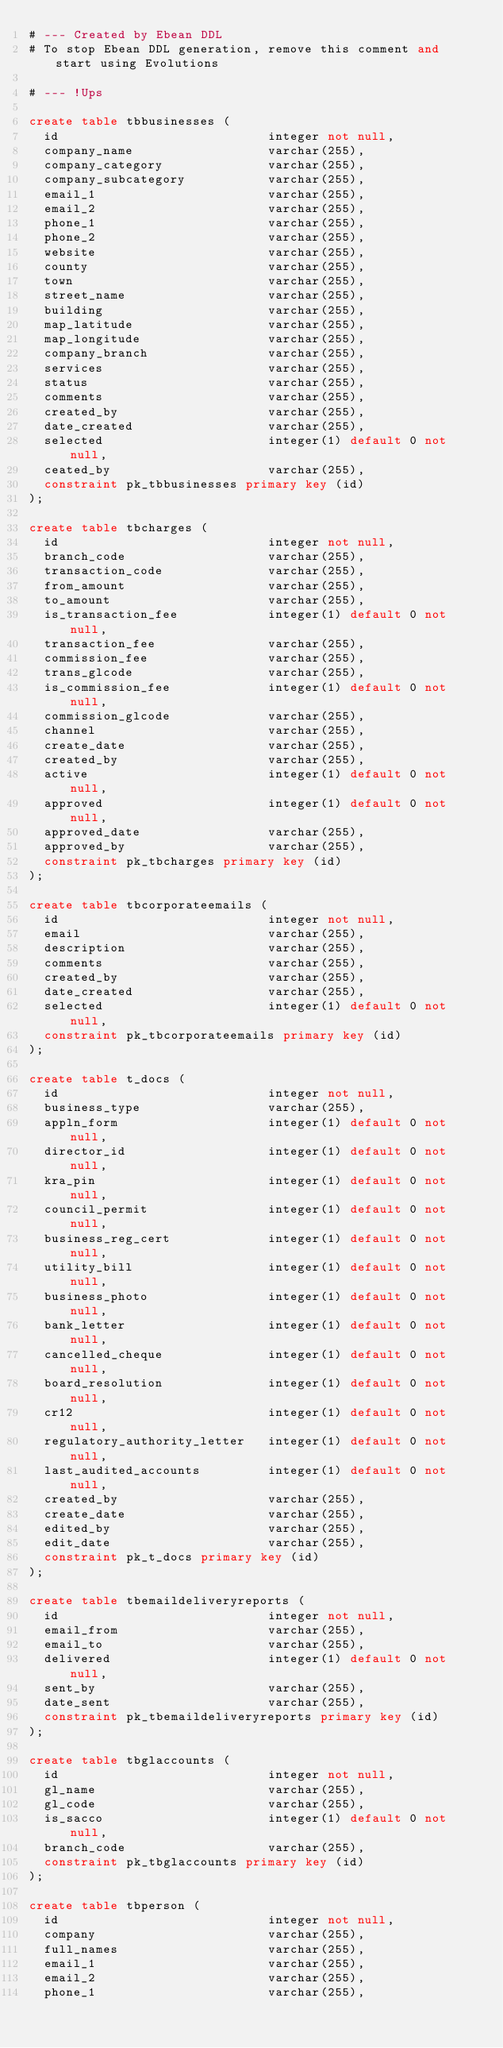<code> <loc_0><loc_0><loc_500><loc_500><_SQL_># --- Created by Ebean DDL
# To stop Ebean DDL generation, remove this comment and start using Evolutions

# --- !Ups

create table tbbusinesses (
  id                            integer not null,
  company_name                  varchar(255),
  company_category              varchar(255),
  company_subcategory           varchar(255),
  email_1                       varchar(255),
  email_2                       varchar(255),
  phone_1                       varchar(255),
  phone_2                       varchar(255),
  website                       varchar(255),
  county                        varchar(255),
  town                          varchar(255),
  street_name                   varchar(255),
  building                      varchar(255),
  map_latitude                  varchar(255),
  map_longitude                 varchar(255),
  company_branch                varchar(255),
  services                      varchar(255),
  status                        varchar(255),
  comments                      varchar(255),
  created_by                    varchar(255),
  date_created                  varchar(255),
  selected                      integer(1) default 0 not null,
  ceated_by                     varchar(255),
  constraint pk_tbbusinesses primary key (id)
);

create table tbcharges (
  id                            integer not null,
  branch_code                   varchar(255),
  transaction_code              varchar(255),
  from_amount                   varchar(255),
  to_amount                     varchar(255),
  is_transaction_fee            integer(1) default 0 not null,
  transaction_fee               varchar(255),
  commission_fee                varchar(255),
  trans_glcode                  varchar(255),
  is_commission_fee             integer(1) default 0 not null,
  commission_glcode             varchar(255),
  channel                       varchar(255),
  create_date                   varchar(255),
  created_by                    varchar(255),
  active                        integer(1) default 0 not null,
  approved                      integer(1) default 0 not null,
  approved_date                 varchar(255),
  approved_by                   varchar(255),
  constraint pk_tbcharges primary key (id)
);

create table tbcorporateemails (
  id                            integer not null,
  email                         varchar(255),
  description                   varchar(255),
  comments                      varchar(255),
  created_by                    varchar(255),
  date_created                  varchar(255),
  selected                      integer(1) default 0 not null,
  constraint pk_tbcorporateemails primary key (id)
);

create table t_docs (
  id                            integer not null,
  business_type                 varchar(255),
  appln_form                    integer(1) default 0 not null,
  director_id                   integer(1) default 0 not null,
  kra_pin                       integer(1) default 0 not null,
  council_permit                integer(1) default 0 not null,
  business_reg_cert             integer(1) default 0 not null,
  utility_bill                  integer(1) default 0 not null,
  business_photo                integer(1) default 0 not null,
  bank_letter                   integer(1) default 0 not null,
  cancelled_cheque              integer(1) default 0 not null,
  board_resolution              integer(1) default 0 not null,
  cr12                          integer(1) default 0 not null,
  regulatory_authority_letter   integer(1) default 0 not null,
  last_audited_accounts         integer(1) default 0 not null,
  created_by                    varchar(255),
  create_date                   varchar(255),
  edited_by                     varchar(255),
  edit_date                     varchar(255),
  constraint pk_t_docs primary key (id)
);

create table tbemaildeliveryreports (
  id                            integer not null,
  email_from                    varchar(255),
  email_to                      varchar(255),
  delivered                     integer(1) default 0 not null,
  sent_by                       varchar(255),
  date_sent                     varchar(255),
  constraint pk_tbemaildeliveryreports primary key (id)
);

create table tbglaccounts (
  id                            integer not null,
  gl_name                       varchar(255),
  gl_code                       varchar(255),
  is_sacco                      integer(1) default 0 not null,
  branch_code                   varchar(255),
  constraint pk_tbglaccounts primary key (id)
);

create table tbperson (
  id                            integer not null,
  company                       varchar(255),
  full_names                    varchar(255),
  email_1                       varchar(255),
  email_2                       varchar(255),
  phone_1                       varchar(255),</code> 